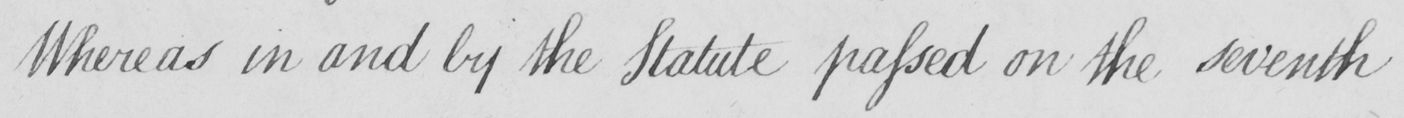What does this handwritten line say? Whereas in and by the Statute passed on the seventh 